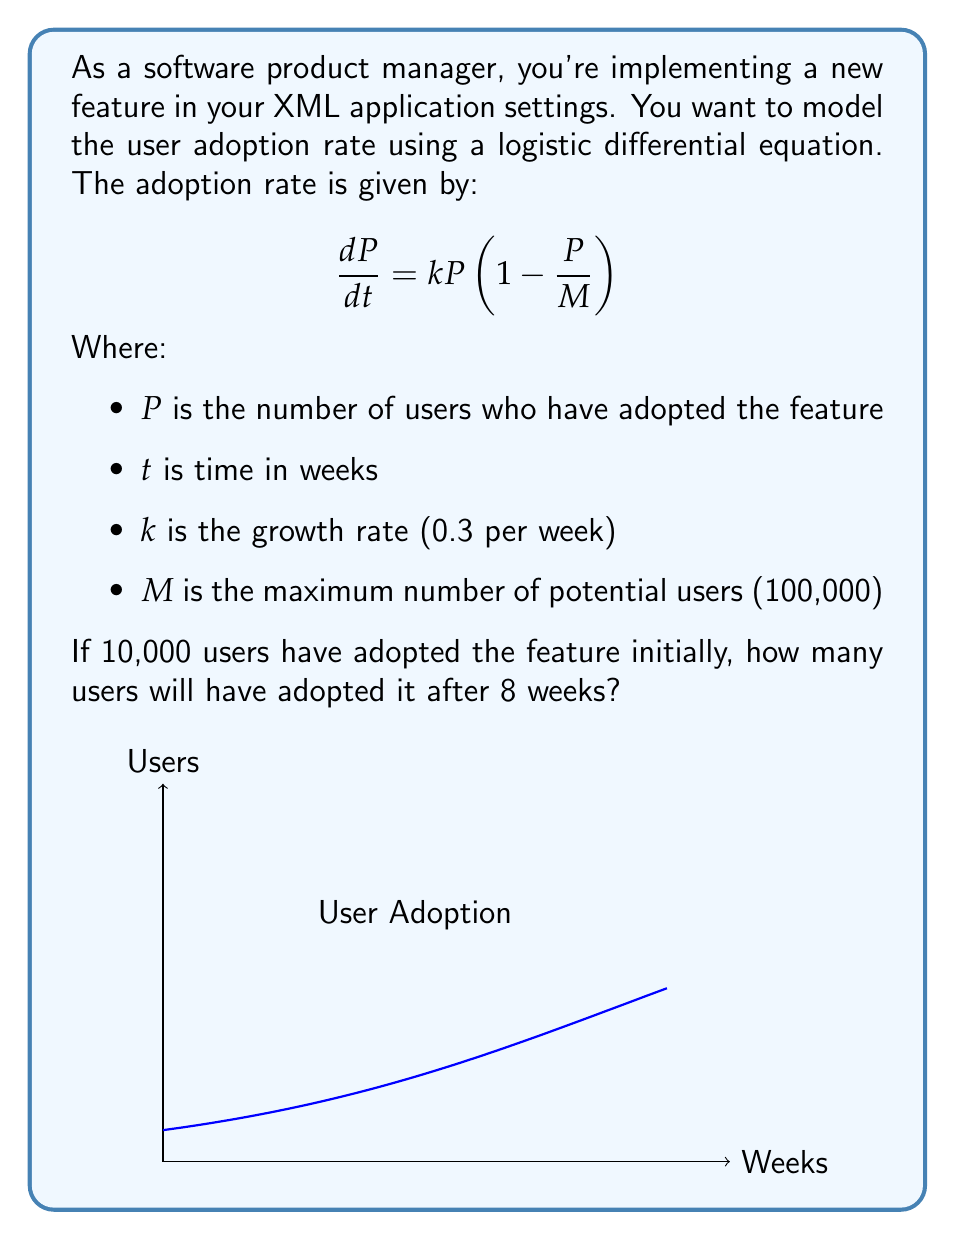Give your solution to this math problem. To solve this problem, we need to use the solution to the logistic differential equation:

$$P(t) = \frac{M}{1 + (\frac{M}{P_0} - 1)e^{-kt}}$$

Where $P_0$ is the initial number of users.

Step 1: Identify the given values
- $M = 100,000$
- $k = 0.3$
- $P_0 = 10,000$
- $t = 8$ weeks

Step 2: Substitute these values into the equation
$$P(8) = \frac{100,000}{1 + (\frac{100,000}{10,000} - 1)e^{-0.3 \cdot 8}}$$

Step 3: Simplify
$$P(8) = \frac{100,000}{1 + 9e^{-2.4}}$$

Step 4: Calculate $e^{-2.4}$
$$e^{-2.4} \approx 0.0907$$

Step 5: Substitute and calculate
$$P(8) = \frac{100,000}{1 + 9 \cdot 0.0907} \approx \frac{100,000}{1.8163} \approx 55,057$$

Therefore, after 8 weeks, approximately 55,057 users will have adopted the new feature.
Answer: 55,057 users 